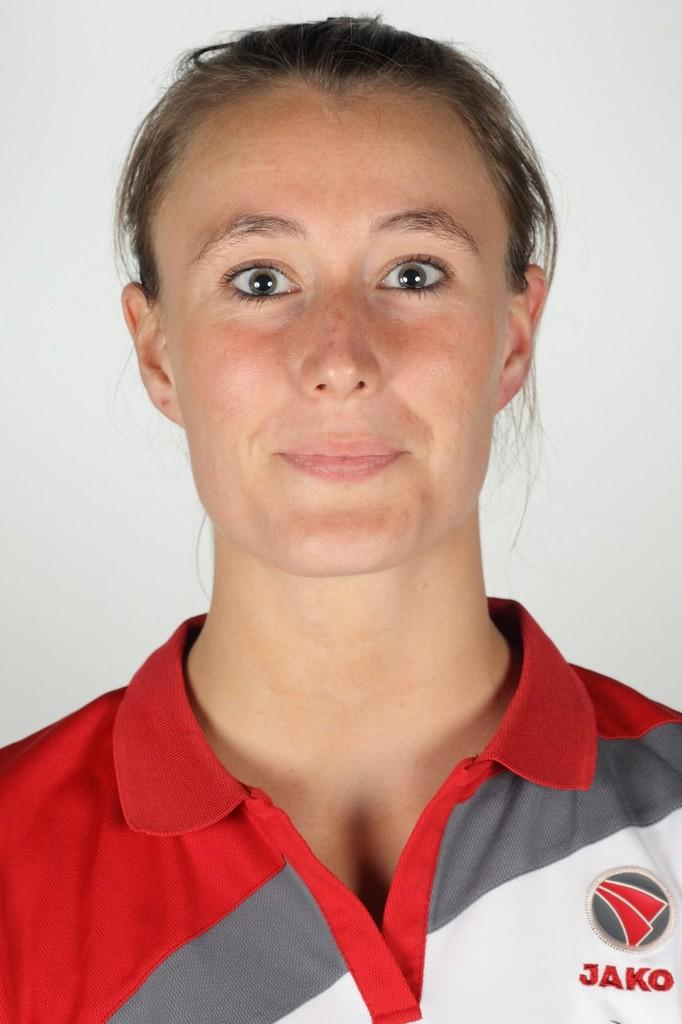<image>
Write a terse but informative summary of the picture. A woman's profile picture and she is wearing a uniform that says JAKO. 